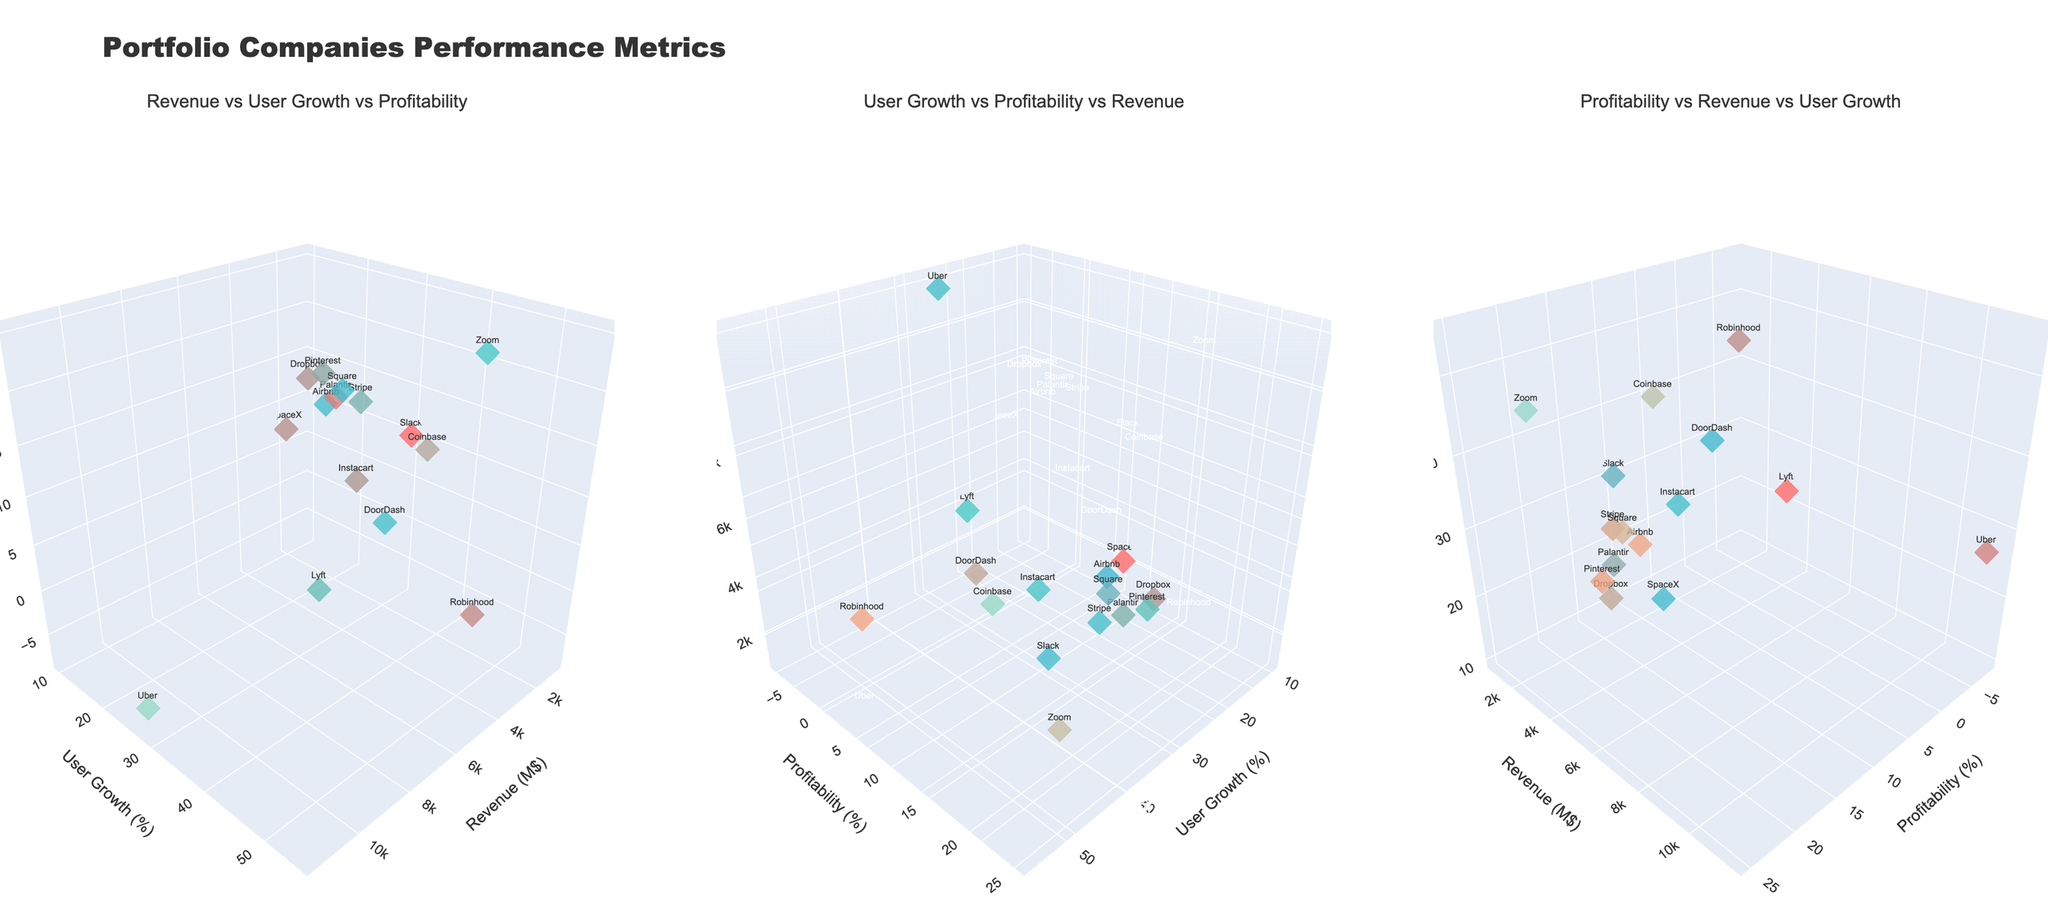What's the title of the figure? The title of the figure is placed at the top center, typically in a larger font to draw attention.
Answer: Portfolio Companies Performance Metrics How many companies are represented in the plots? Count the distinct data points or markers, each corresponding to a company, across the subplots. Here, each subplot visualizes the same dataset.
Answer: 15 Which company shows the highest user growth? Identify the marker positioned at the highest value on the User Growth axis in any of the subplots.
Answer: Coinbase What is the revenue range shown in the plots? Determine the minimum and maximum values on the Revenue axis by observing the relevant subplot where Revenue is an axis.
Answer: 950M$ to 11500M$ Between Airbnb and Uber, which company is more profitable? Compare the values on the Profitability axis for the markers labelled as Airbnb and Uber across the subplots.
Answer: Airbnb Which company has the lowest profitability? Locate the marker at the lowest point on the Profitability axis in any of the subplots to find the company with the least profitability.
Answer: Lyft What is the combined user growth of Airbnb and DoorDash? Add the User Growth percentages of Airbnb and DoorDash by checking the values next to these companies in the relevant axis. Airbnb: 32%, DoorDash: 40%.
Answer: 72% Which subplot shows Revenue on the Z axis? Identify and describe which of the three subplots places Revenue as the vertical axis.
Answer: User Growth vs Profitability vs Revenue How does Robinhood's profitability compare to Palantir's? Look at the Profitability axis values for Robinhood and Palantir in any of the subplots. Robinhood: -5%, Palantir: 12%.
Answer: Robinhood is less profitable Is there a company with a high revenue but negative profitability? Analyze the subplots and identify any markers that are high on the Revenue axis but negative on the Profitability axis.
Answer: Uber 